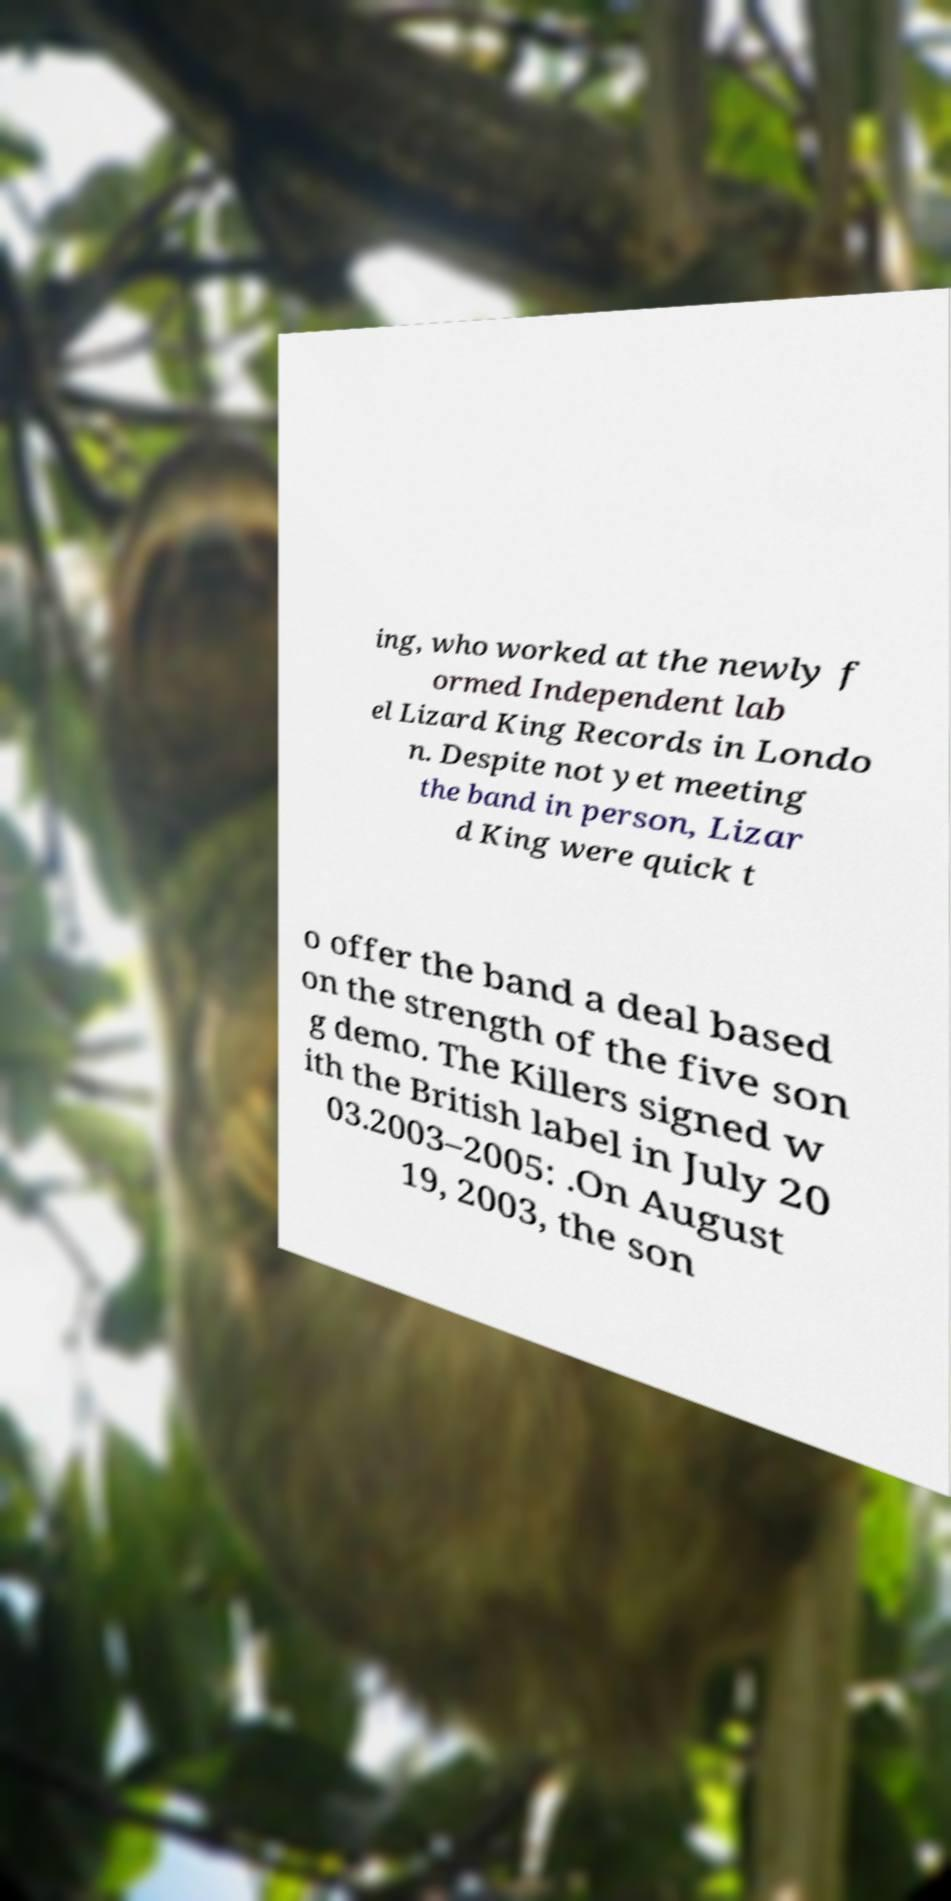Please identify and transcribe the text found in this image. ing, who worked at the newly f ormed Independent lab el Lizard King Records in Londo n. Despite not yet meeting the band in person, Lizar d King were quick t o offer the band a deal based on the strength of the five son g demo. The Killers signed w ith the British label in July 20 03.2003–2005: .On August 19, 2003, the son 